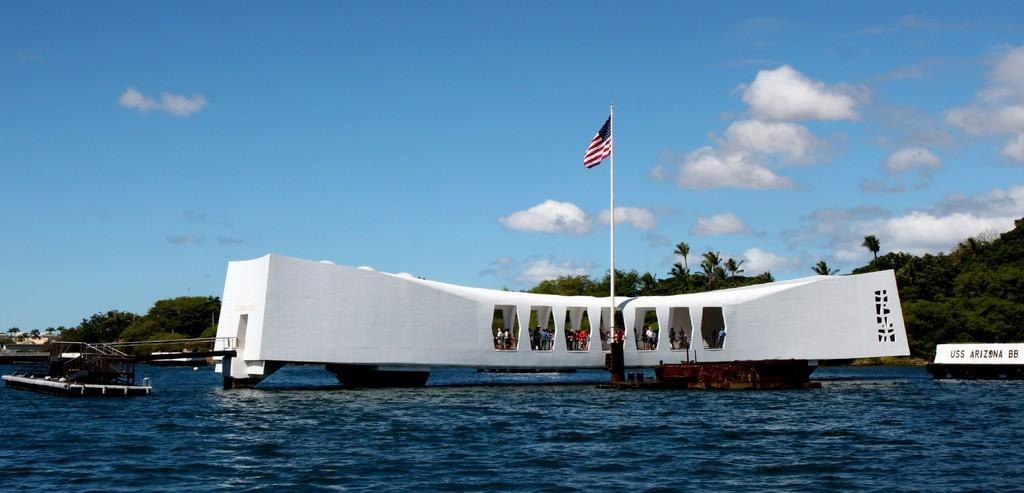<image>
Write a terse but informative summary of the picture. A white building next to a boat reading USS Arizona 